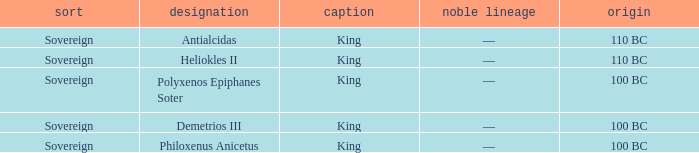Which royal house corresponds to Polyxenos Epiphanes Soter? —. Parse the table in full. {'header': ['sort', 'designation', 'caption', 'noble lineage', 'origin'], 'rows': [['Sovereign', 'Antialcidas', 'King', '—', '110 BC'], ['Sovereign', 'Heliokles II', 'King', '—', '110 BC'], ['Sovereign', 'Polyxenos Epiphanes Soter', 'King', '—', '100 BC'], ['Sovereign', 'Demetrios III', 'King', '—', '100 BC'], ['Sovereign', 'Philoxenus Anicetus', 'King', '—', '100 BC']]} 